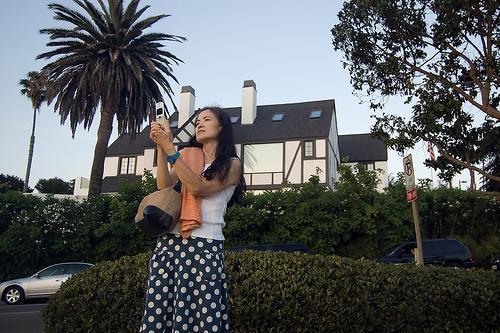How many people in the picture?
Give a very brief answer. 1. 